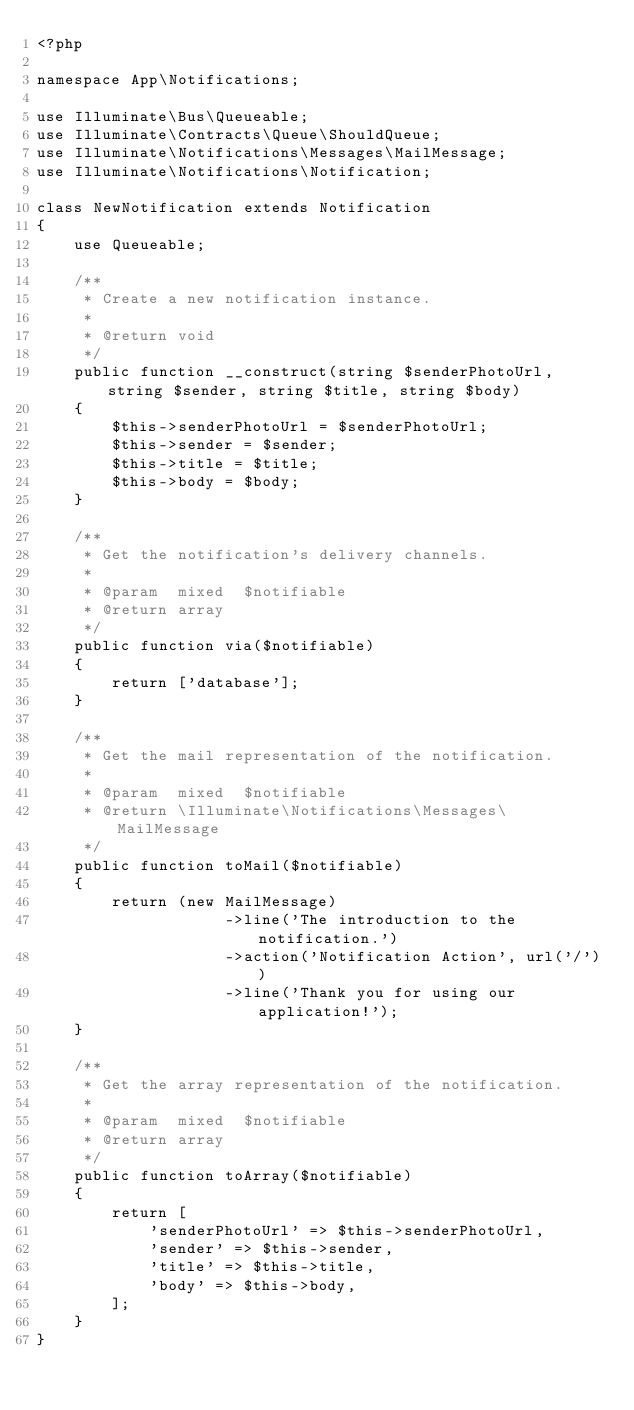Convert code to text. <code><loc_0><loc_0><loc_500><loc_500><_PHP_><?php

namespace App\Notifications;

use Illuminate\Bus\Queueable;
use Illuminate\Contracts\Queue\ShouldQueue;
use Illuminate\Notifications\Messages\MailMessage;
use Illuminate\Notifications\Notification;

class NewNotification extends Notification
{
    use Queueable;

    /**
     * Create a new notification instance.
     *
     * @return void
     */
    public function __construct(string $senderPhotoUrl, string $sender, string $title, string $body)
    {
        $this->senderPhotoUrl = $senderPhotoUrl;
        $this->sender = $sender;
        $this->title = $title;
        $this->body = $body;
    }

    /**
     * Get the notification's delivery channels.
     *
     * @param  mixed  $notifiable
     * @return array
     */
    public function via($notifiable)
    {
        return ['database'];
    }

    /**
     * Get the mail representation of the notification.
     *
     * @param  mixed  $notifiable
     * @return \Illuminate\Notifications\Messages\MailMessage
     */
    public function toMail($notifiable)
    {
        return (new MailMessage)
                    ->line('The introduction to the notification.')
                    ->action('Notification Action', url('/'))
                    ->line('Thank you for using our application!');
    }

    /**
     * Get the array representation of the notification.
     *
     * @param  mixed  $notifiable
     * @return array
     */
    public function toArray($notifiable)
    {
        return [
            'senderPhotoUrl' => $this->senderPhotoUrl,
            'sender' => $this->sender,
            'title' => $this->title,
            'body' => $this->body,
        ];
    }
}
</code> 